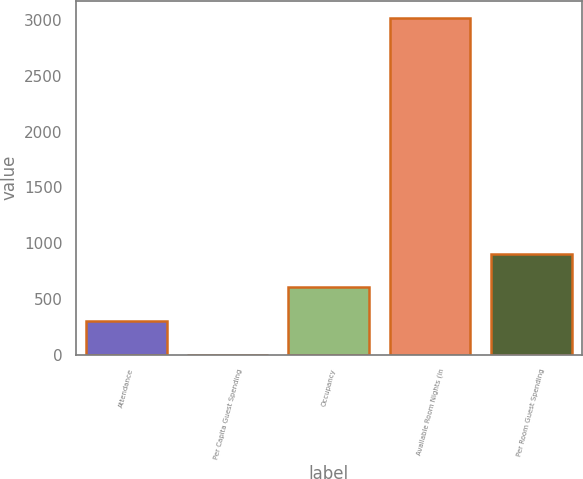Convert chart. <chart><loc_0><loc_0><loc_500><loc_500><bar_chart><fcel>Attendance<fcel>Per Capita Guest Spending<fcel>Occupancy<fcel>Available Room Nights (in<fcel>Per Room Guest Spending<nl><fcel>303.1<fcel>1<fcel>605.2<fcel>3022<fcel>907.3<nl></chart> 